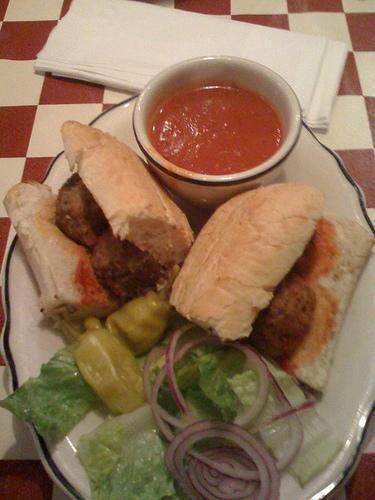How many sandwiches are there?
Give a very brief answer. 2. How many people are there wearing black shirts?
Give a very brief answer. 0. 